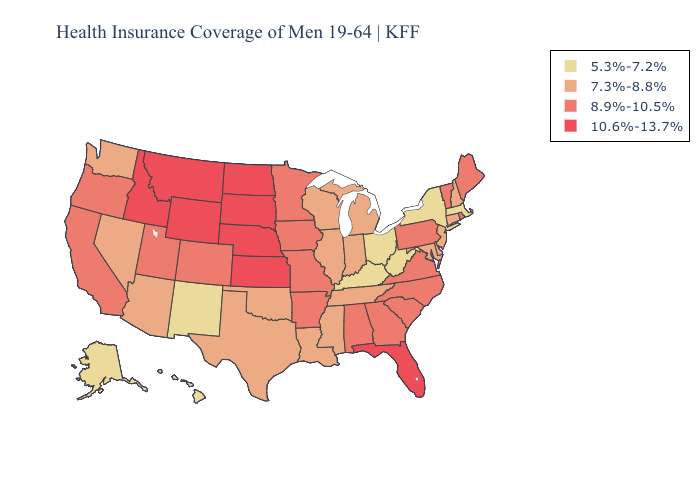Does Vermont have the lowest value in the USA?
Short answer required. No. Does Oklahoma have a lower value than Tennessee?
Quick response, please. No. Does New York have the lowest value in the USA?
Concise answer only. Yes. What is the value of New Hampshire?
Be succinct. 7.3%-8.8%. What is the value of Montana?
Be succinct. 10.6%-13.7%. Does Idaho have the highest value in the West?
Give a very brief answer. Yes. What is the lowest value in the South?
Write a very short answer. 5.3%-7.2%. Does Maine have a lower value than Illinois?
Quick response, please. No. Does Oklahoma have a lower value than Arkansas?
Answer briefly. Yes. Name the states that have a value in the range 5.3%-7.2%?
Quick response, please. Alaska, Hawaii, Kentucky, Massachusetts, New Mexico, New York, Ohio, West Virginia. Does Kentucky have the lowest value in the South?
Keep it brief. Yes. Among the states that border South Carolina , which have the lowest value?
Quick response, please. Georgia, North Carolina. Does California have the same value as Louisiana?
Quick response, please. No. Does New York have the lowest value in the USA?
Answer briefly. Yes. Name the states that have a value in the range 5.3%-7.2%?
Concise answer only. Alaska, Hawaii, Kentucky, Massachusetts, New Mexico, New York, Ohio, West Virginia. 